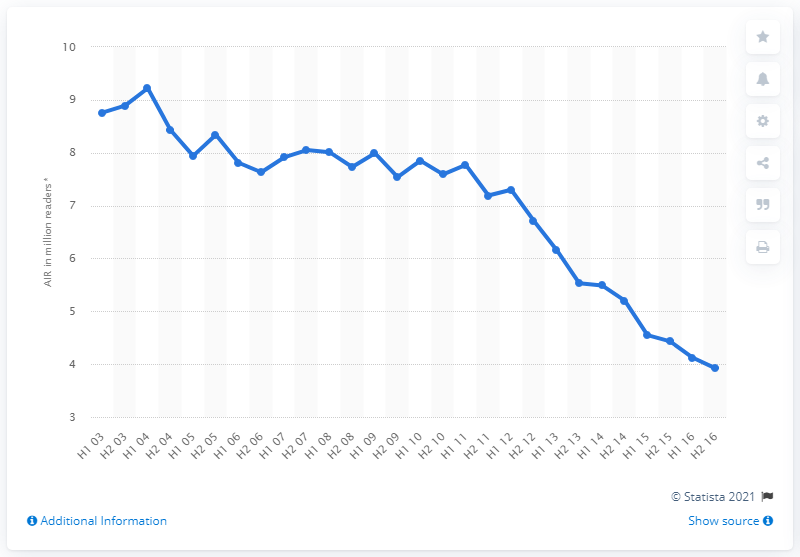Highlight a few significant elements in this photo. The Sun's readership in the UK from July to December 2015 was 4.43 million. 